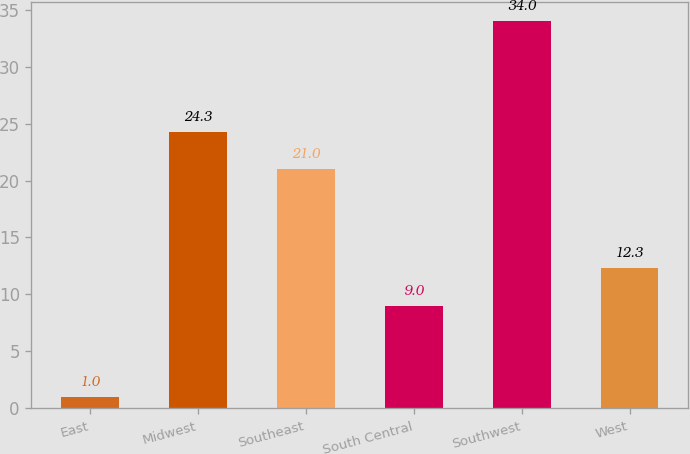Convert chart to OTSL. <chart><loc_0><loc_0><loc_500><loc_500><bar_chart><fcel>East<fcel>Midwest<fcel>Southeast<fcel>South Central<fcel>Southwest<fcel>West<nl><fcel>1<fcel>24.3<fcel>21<fcel>9<fcel>34<fcel>12.3<nl></chart> 